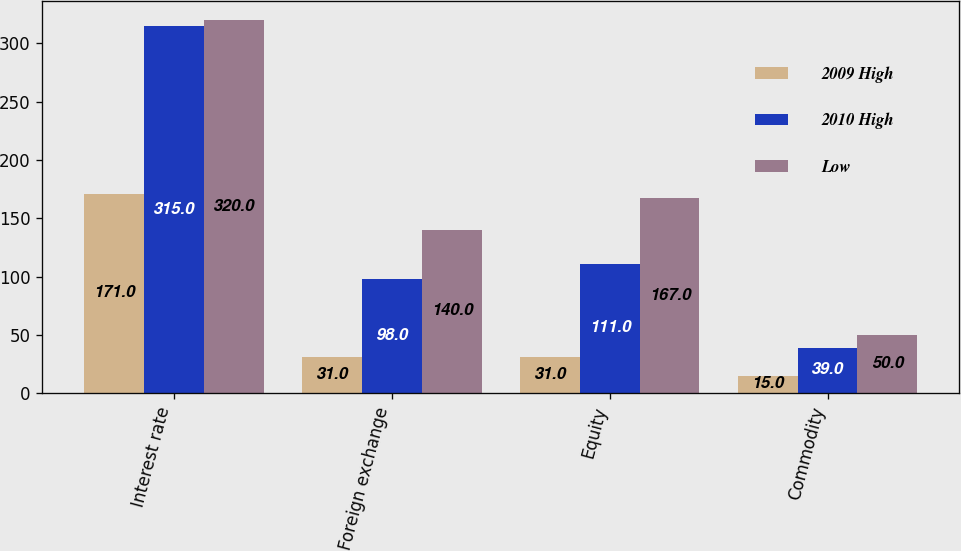Convert chart. <chart><loc_0><loc_0><loc_500><loc_500><stacked_bar_chart><ecel><fcel>Interest rate<fcel>Foreign exchange<fcel>Equity<fcel>Commodity<nl><fcel>2009 High<fcel>171<fcel>31<fcel>31<fcel>15<nl><fcel>2010 High<fcel>315<fcel>98<fcel>111<fcel>39<nl><fcel>Low<fcel>320<fcel>140<fcel>167<fcel>50<nl></chart> 